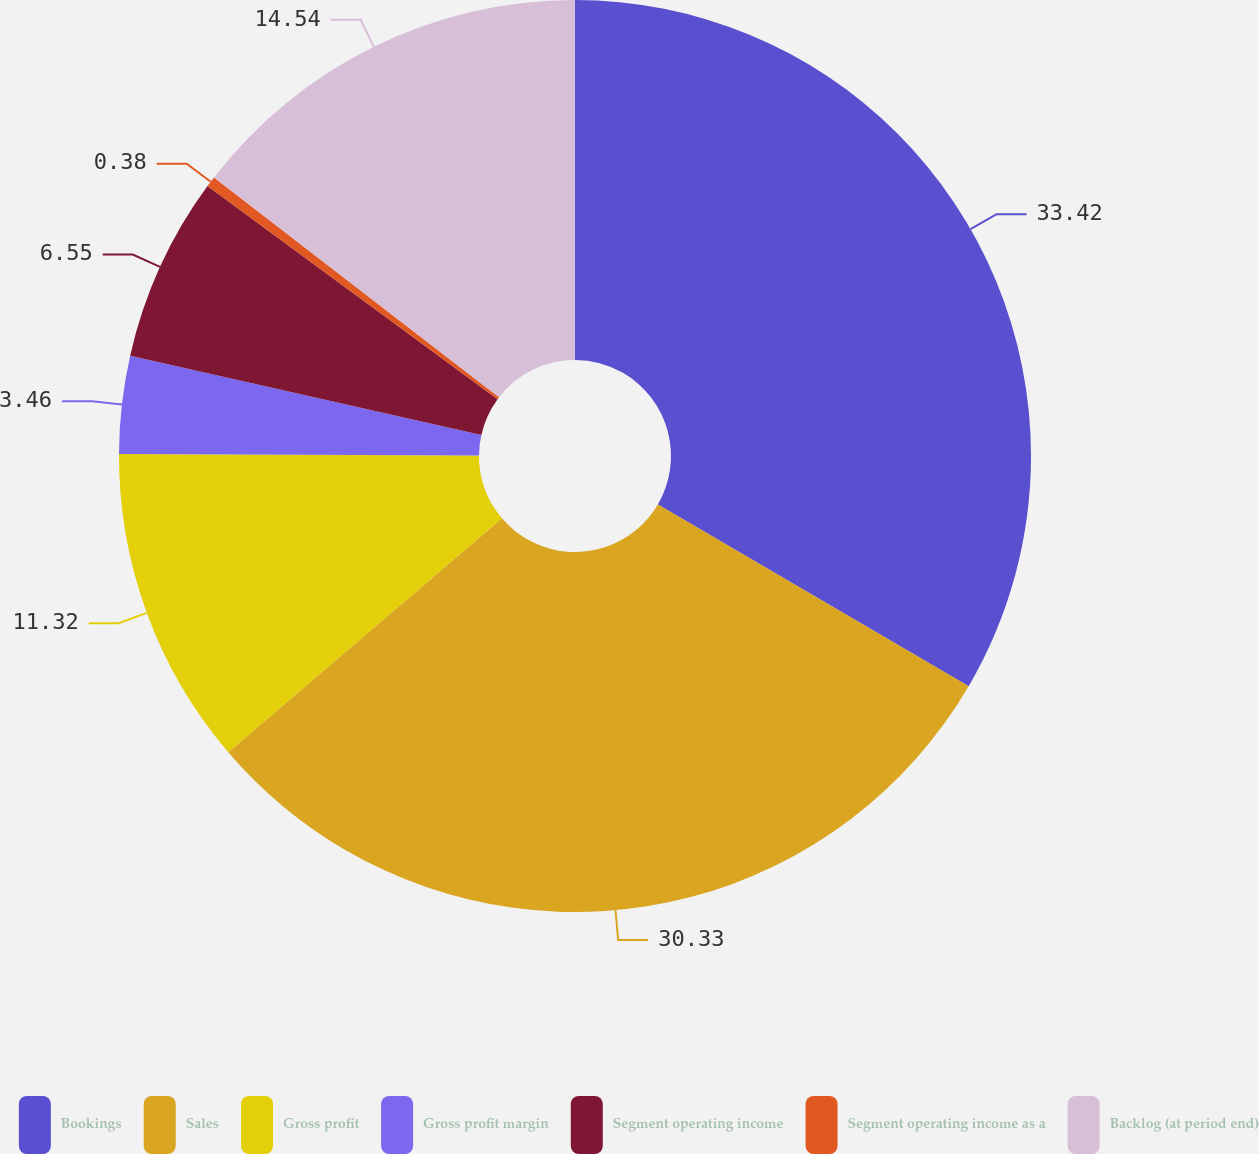Convert chart to OTSL. <chart><loc_0><loc_0><loc_500><loc_500><pie_chart><fcel>Bookings<fcel>Sales<fcel>Gross profit<fcel>Gross profit margin<fcel>Segment operating income<fcel>Segment operating income as a<fcel>Backlog (at period end)<nl><fcel>33.42%<fcel>30.33%<fcel>11.32%<fcel>3.46%<fcel>6.55%<fcel>0.38%<fcel>14.54%<nl></chart> 